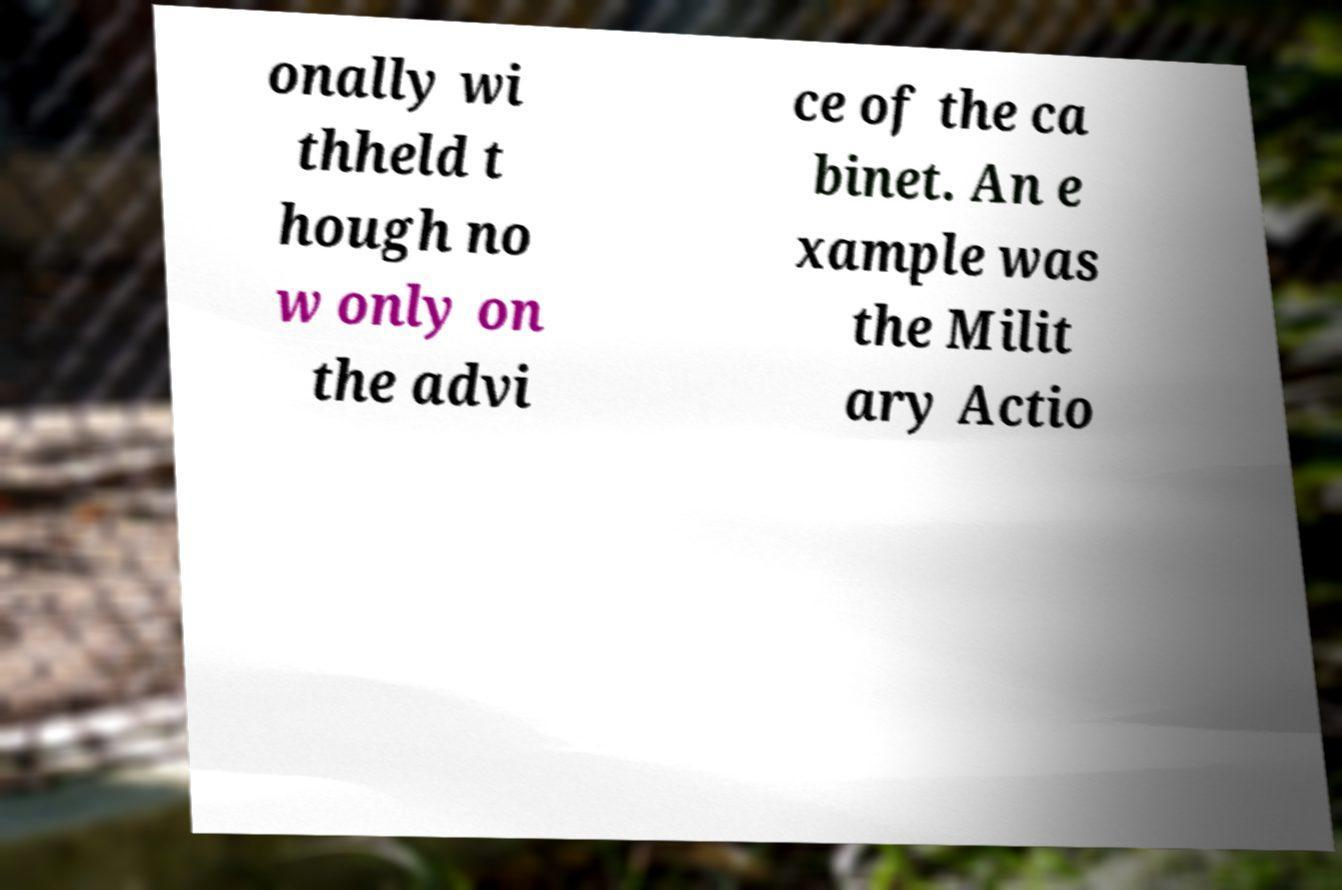Could you extract and type out the text from this image? onally wi thheld t hough no w only on the advi ce of the ca binet. An e xample was the Milit ary Actio 